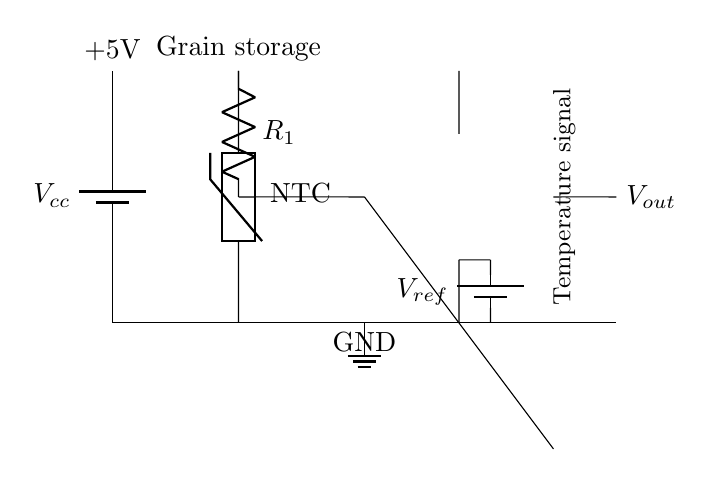What component measures temperature in the circuit? The circuit uses a thermistor, specifically a negative temperature coefficient (NTC) thermistor, which decreases resistance as temperature increases.
Answer: thermistor What is the supply voltage for this circuit? The circuit is supplied with a voltage of 5 volts, as indicated by the label next to the battery symbol.
Answer: 5 volts What type of connection is used between the resistor and the operational amplifier? The connection between the resistor and the operational amplifier is a short connection, indicated by the line drawn directly between them.
Answer: short What is the purpose of the reference voltage in this circuit? The reference voltage, provided by the second battery, is used as a comparison point for the operational amplifier to determine the output voltage.
Answer: comparison point What does the output voltage represent in the circuit? The output voltage represents the temperature signal processed by the operational amplifier based on the input from the thermistor and resistor network.
Answer: temperature signal How many main components are present in this circuit? There are five main components in the circuit: a battery, a thermistor, a resistor, an operational amplifier, and a second battery for reference voltage.
Answer: five What is the role of the resistor in this temperature sensing circuit? The resistor forms a voltage divider with the thermistor, which allows the operational amplifier to interpret the voltage change caused by temperature variations.
Answer: voltage divider 